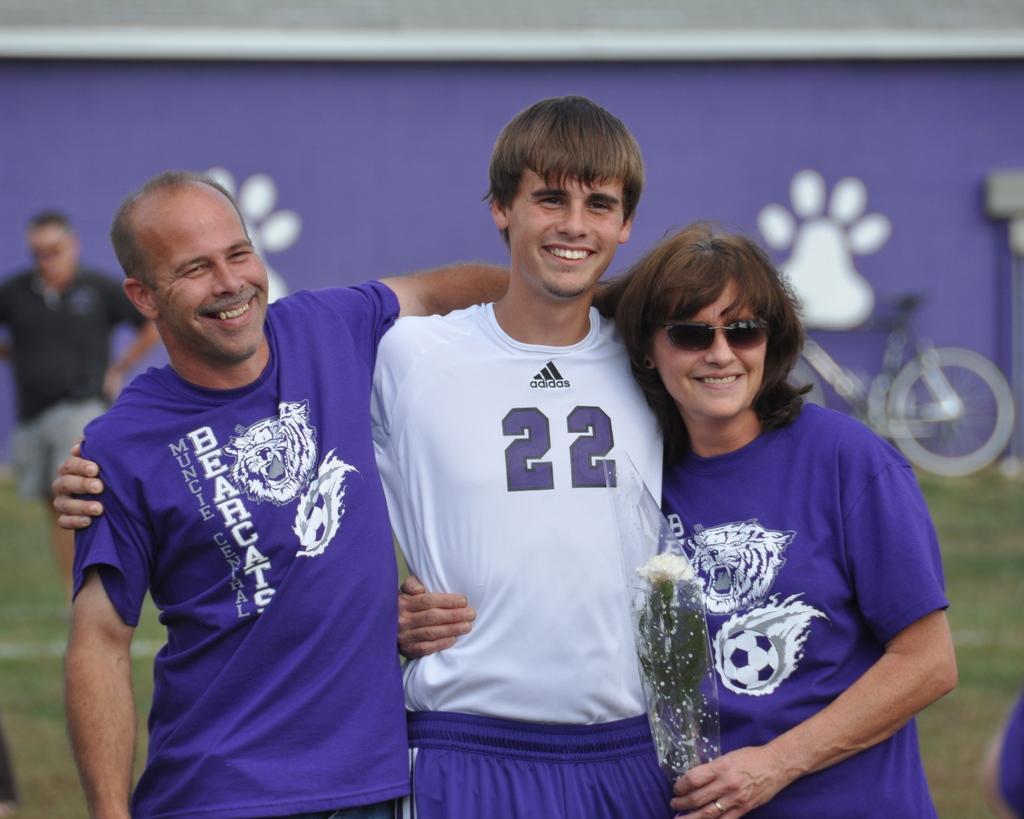Please provide a concise description of this image. In the middle of the image three persons are standing and smiling. Behind them there is grass and bicycles and banner. Background of the image is blur. 